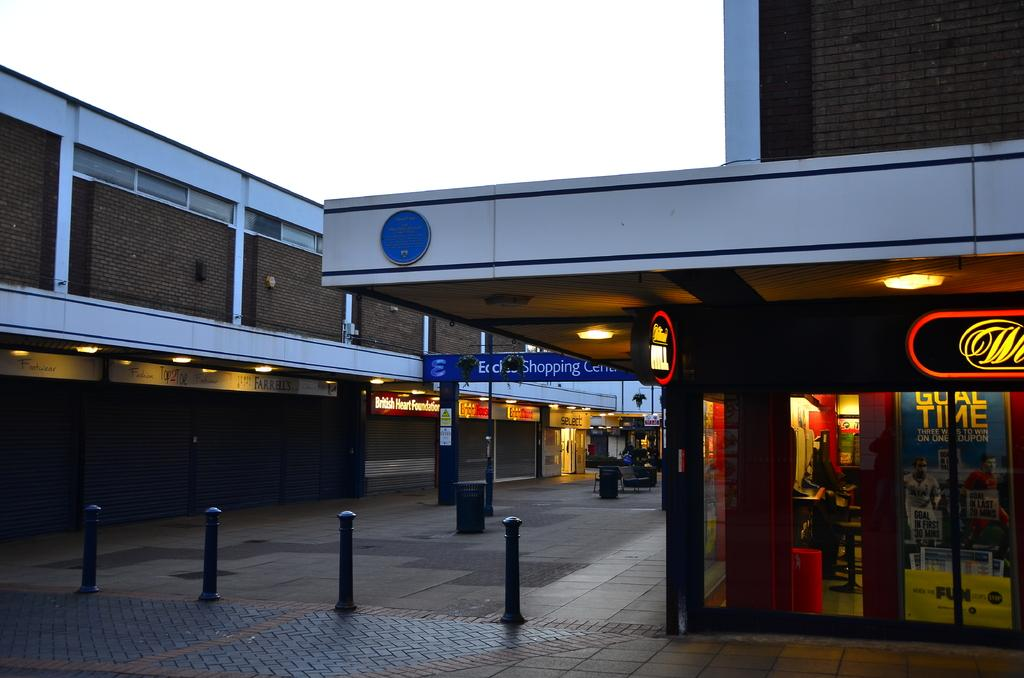<image>
Write a terse but informative summary of the picture. Shopping Center is advertised on the banner over this building. 